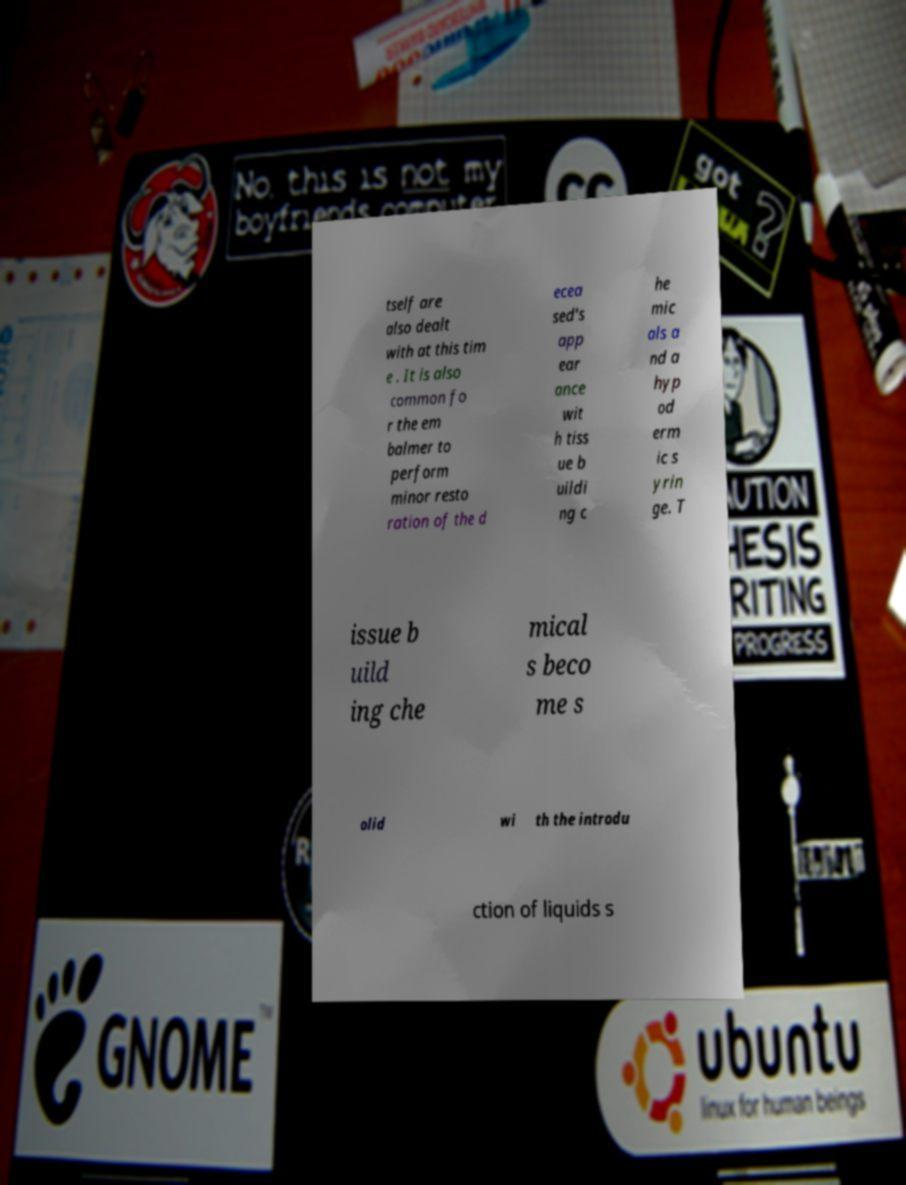What messages or text are displayed in this image? I need them in a readable, typed format. tself are also dealt with at this tim e . It is also common fo r the em balmer to perform minor resto ration of the d ecea sed's app ear ance wit h tiss ue b uildi ng c he mic als a nd a hyp od erm ic s yrin ge. T issue b uild ing che mical s beco me s olid wi th the introdu ction of liquids s 